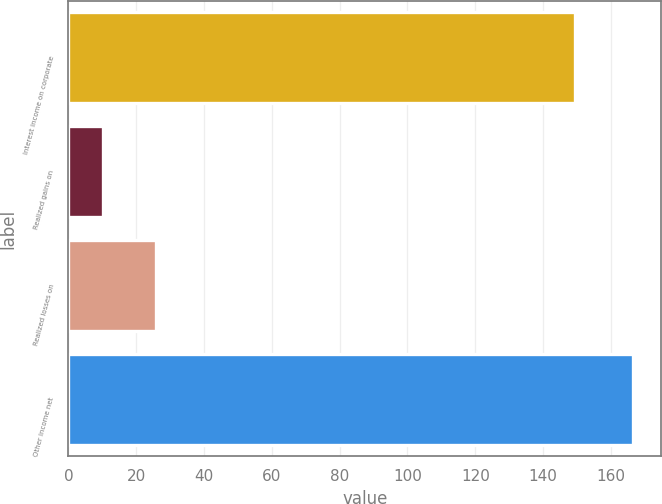Convert chart to OTSL. <chart><loc_0><loc_0><loc_500><loc_500><bar_chart><fcel>Interest income on corporate<fcel>Realized gains on<fcel>Realized losses on<fcel>Other income net<nl><fcel>149.5<fcel>10.1<fcel>25.74<fcel>166.5<nl></chart> 